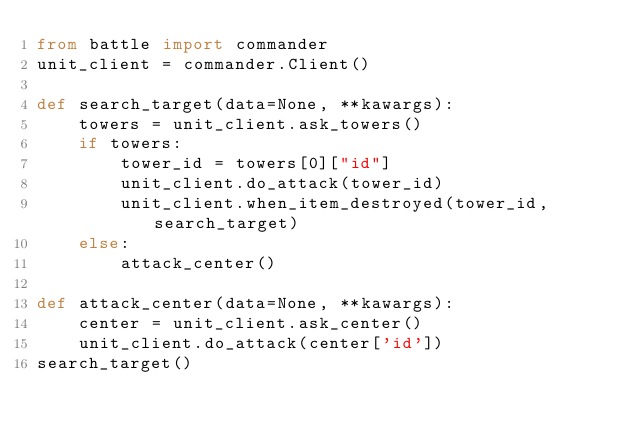Convert code to text. <code><loc_0><loc_0><loc_500><loc_500><_Python_>from battle import commander
unit_client = commander.Client()

def search_target(data=None, **kawargs):
    towers = unit_client.ask_towers()
    if towers:
        tower_id = towers[0]["id"]
        unit_client.do_attack(tower_id)
        unit_client.when_item_destroyed(tower_id, search_target)
    else:
        attack_center()

def attack_center(data=None, **kawargs):
    center = unit_client.ask_center()
    unit_client.do_attack(center['id'])
search_target()
</code> 